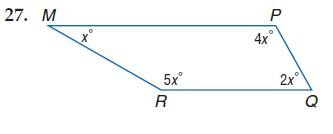Answer the mathemtical geometry problem and directly provide the correct option letter.
Question: Find m \angle R.
Choices: A: 30 B: 60 C: 120 D: 150 D 